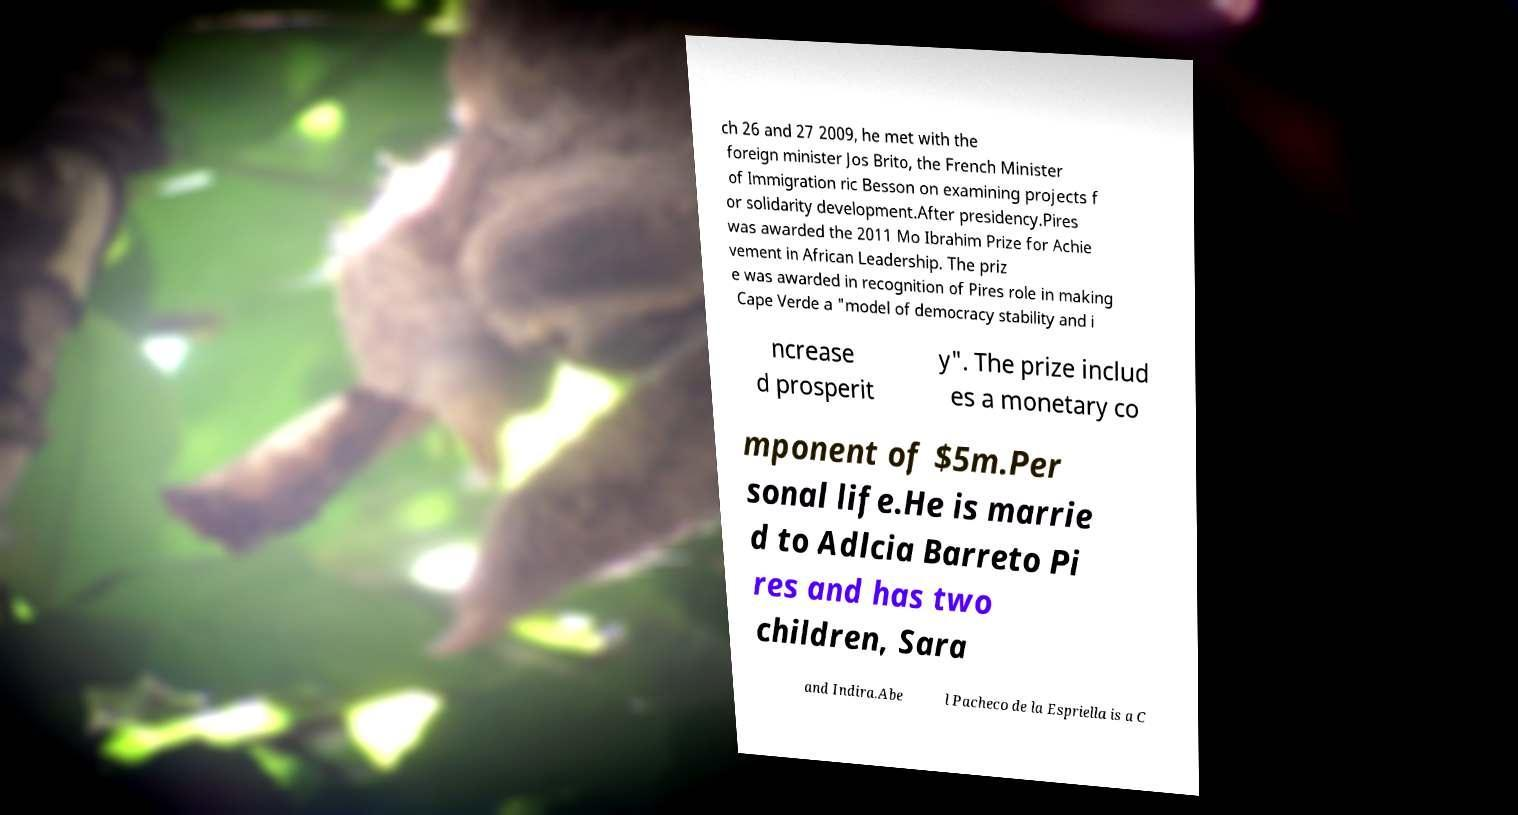There's text embedded in this image that I need extracted. Can you transcribe it verbatim? ch 26 and 27 2009, he met with the foreign minister Jos Brito, the French Minister of Immigration ric Besson on examining projects f or solidarity development.After presidency.Pires was awarded the 2011 Mo Ibrahim Prize for Achie vement in African Leadership. The priz e was awarded in recognition of Pires role in making Cape Verde a "model of democracy stability and i ncrease d prosperit y". The prize includ es a monetary co mponent of $5m.Per sonal life.He is marrie d to Adlcia Barreto Pi res and has two children, Sara and Indira.Abe l Pacheco de la Espriella is a C 